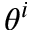Convert formula to latex. <formula><loc_0><loc_0><loc_500><loc_500>\theta ^ { i }</formula> 